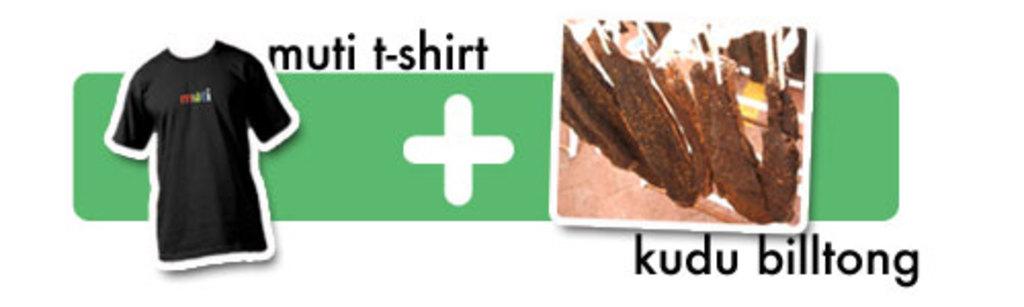What kind of t-shirt is this?
Your response must be concise. Muti. What is added to the t-shirt?
Provide a succinct answer. Kudu billtong. 